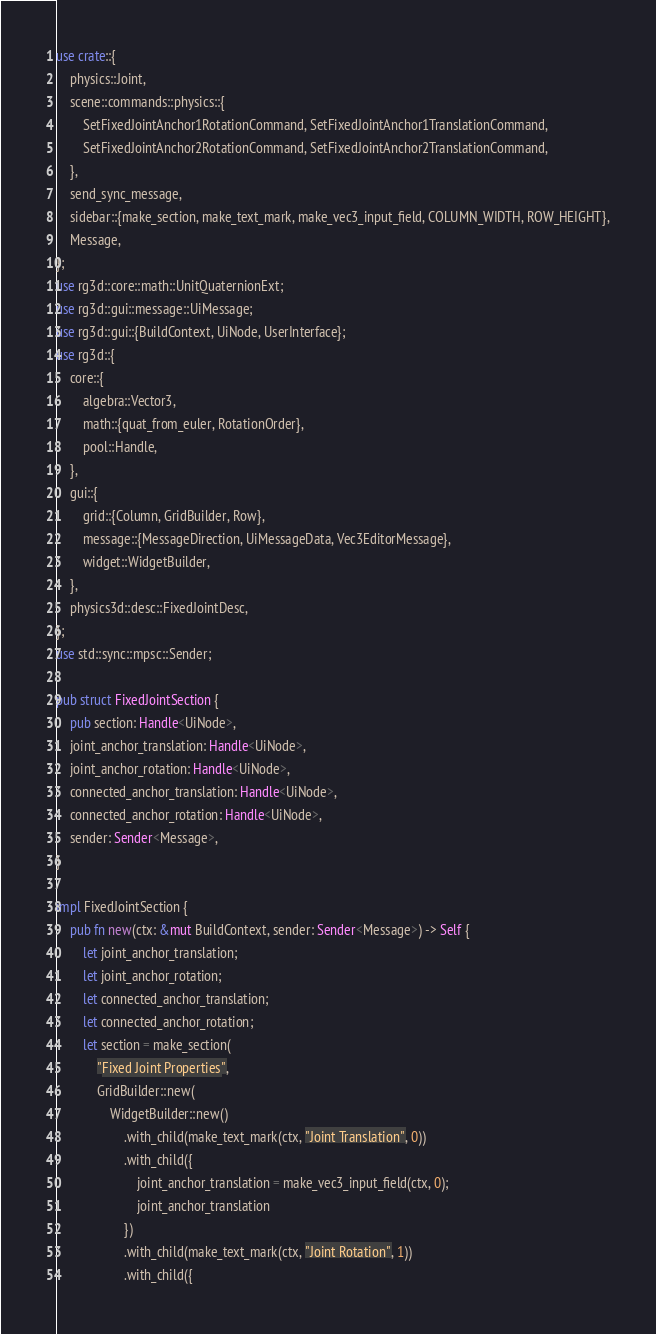<code> <loc_0><loc_0><loc_500><loc_500><_Rust_>use crate::{
    physics::Joint,
    scene::commands::physics::{
        SetFixedJointAnchor1RotationCommand, SetFixedJointAnchor1TranslationCommand,
        SetFixedJointAnchor2RotationCommand, SetFixedJointAnchor2TranslationCommand,
    },
    send_sync_message,
    sidebar::{make_section, make_text_mark, make_vec3_input_field, COLUMN_WIDTH, ROW_HEIGHT},
    Message,
};
use rg3d::core::math::UnitQuaternionExt;
use rg3d::gui::message::UiMessage;
use rg3d::gui::{BuildContext, UiNode, UserInterface};
use rg3d::{
    core::{
        algebra::Vector3,
        math::{quat_from_euler, RotationOrder},
        pool::Handle,
    },
    gui::{
        grid::{Column, GridBuilder, Row},
        message::{MessageDirection, UiMessageData, Vec3EditorMessage},
        widget::WidgetBuilder,
    },
    physics3d::desc::FixedJointDesc,
};
use std::sync::mpsc::Sender;

pub struct FixedJointSection {
    pub section: Handle<UiNode>,
    joint_anchor_translation: Handle<UiNode>,
    joint_anchor_rotation: Handle<UiNode>,
    connected_anchor_translation: Handle<UiNode>,
    connected_anchor_rotation: Handle<UiNode>,
    sender: Sender<Message>,
}

impl FixedJointSection {
    pub fn new(ctx: &mut BuildContext, sender: Sender<Message>) -> Self {
        let joint_anchor_translation;
        let joint_anchor_rotation;
        let connected_anchor_translation;
        let connected_anchor_rotation;
        let section = make_section(
            "Fixed Joint Properties",
            GridBuilder::new(
                WidgetBuilder::new()
                    .with_child(make_text_mark(ctx, "Joint Translation", 0))
                    .with_child({
                        joint_anchor_translation = make_vec3_input_field(ctx, 0);
                        joint_anchor_translation
                    })
                    .with_child(make_text_mark(ctx, "Joint Rotation", 1))
                    .with_child({</code> 